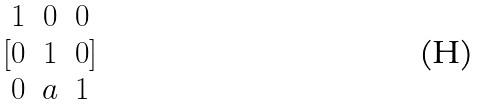<formula> <loc_0><loc_0><loc_500><loc_500>[ \begin{matrix} 1 & 0 & 0 \\ 0 & 1 & 0 \\ 0 & a & 1 \end{matrix} ]</formula> 